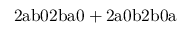<formula> <loc_0><loc_0><loc_500><loc_500>2 a b 0 2 b a 0 + 2 a 0 b 2 b 0 a</formula> 